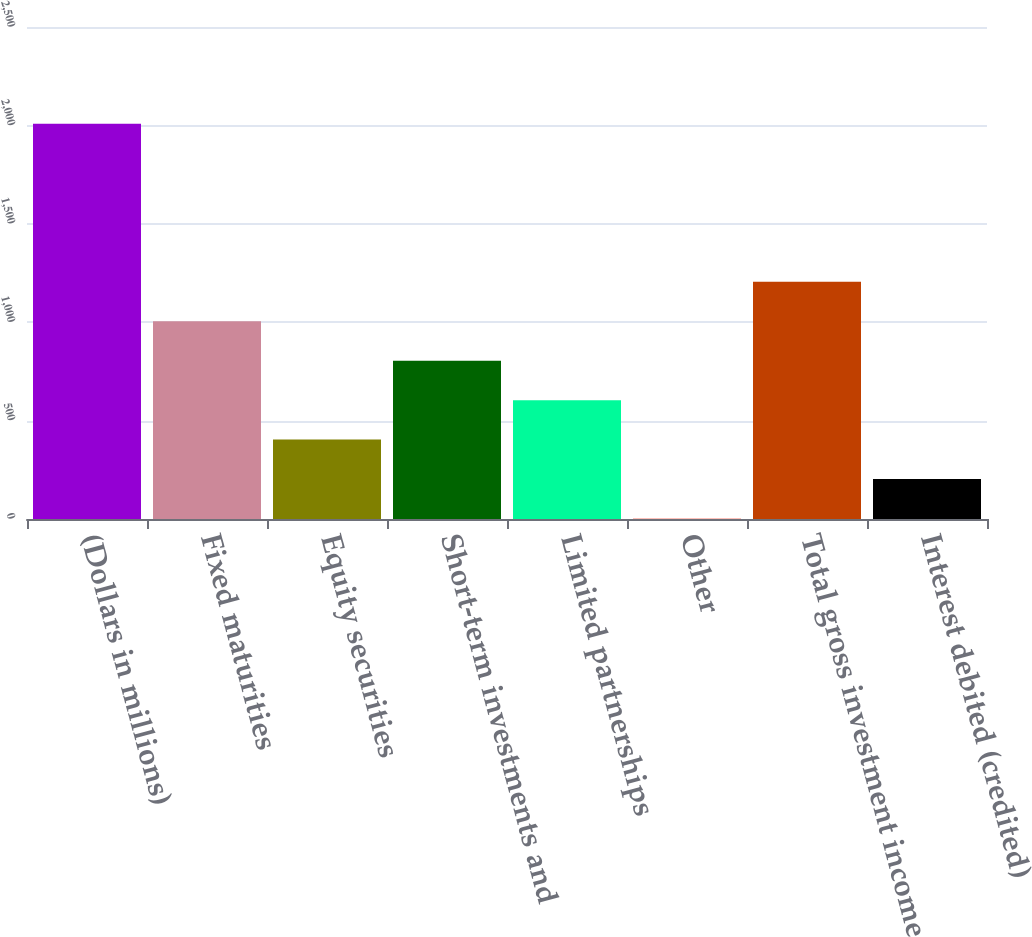<chart> <loc_0><loc_0><loc_500><loc_500><bar_chart><fcel>(Dollars in millions)<fcel>Fixed maturities<fcel>Equity securities<fcel>Short-term investments and<fcel>Limited partnerships<fcel>Other<fcel>Total gross investment income<fcel>Interest debited (credited)<nl><fcel>2008<fcel>1005.15<fcel>403.44<fcel>804.58<fcel>604.01<fcel>2.3<fcel>1205.72<fcel>202.87<nl></chart> 